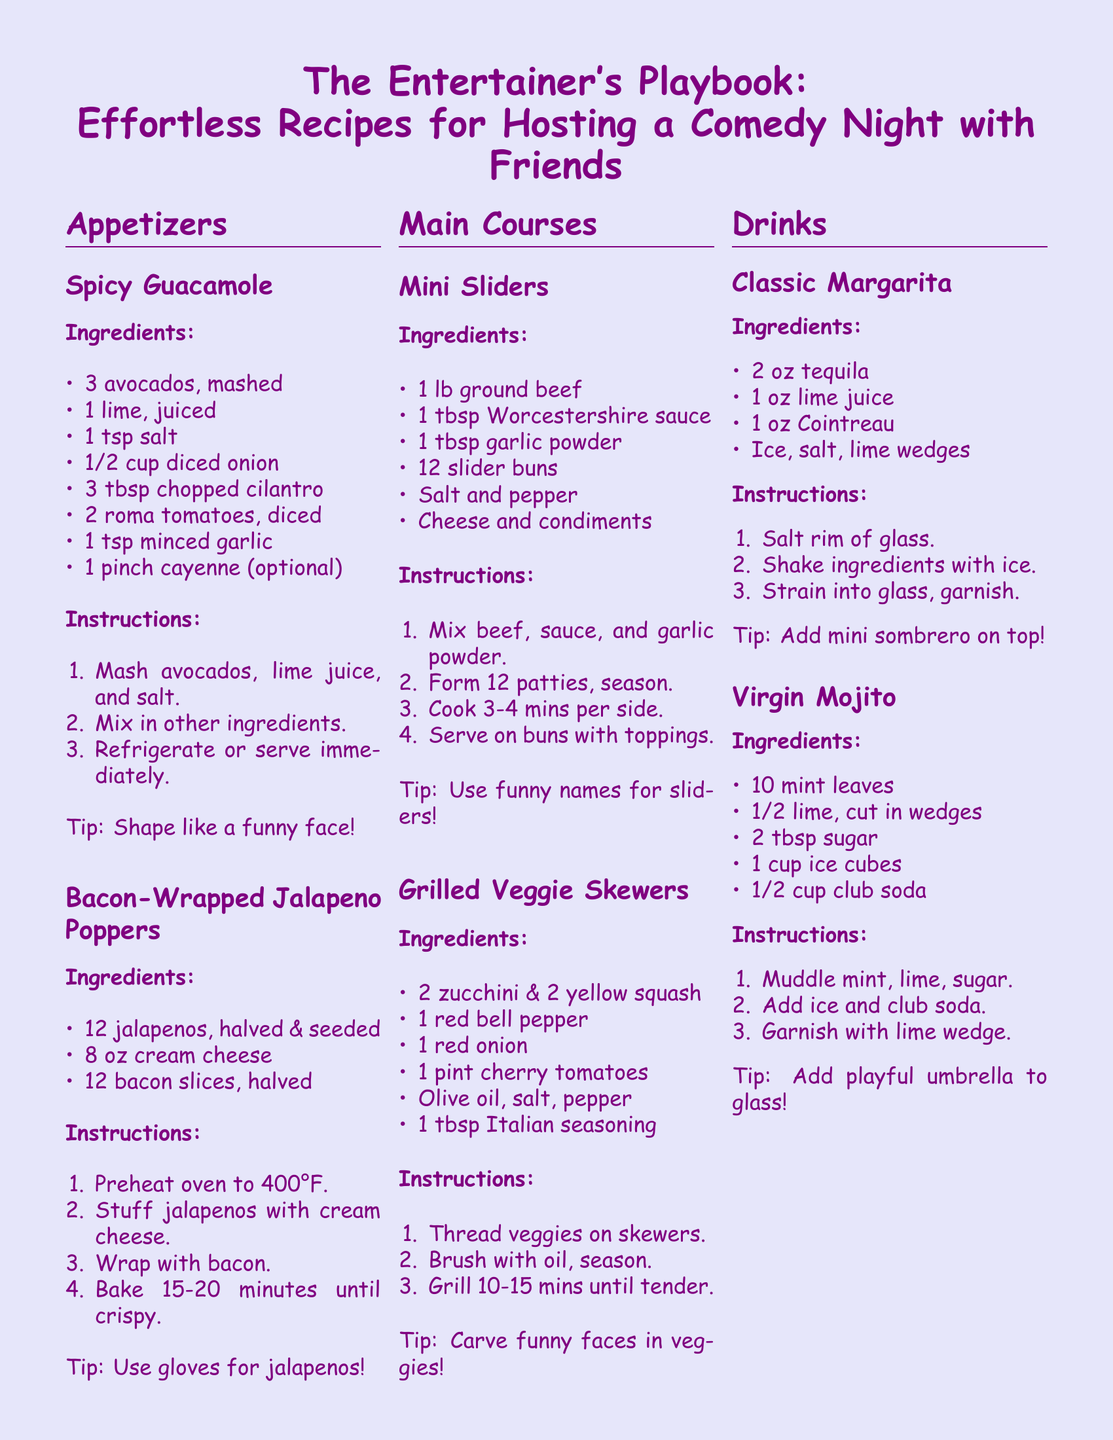What is the primary theme of the document? The document is focused on providing recipes and tips for hosting a comedy night with friends.
Answer: Hosting a comedy night How many ingredients are listed for the Spicy Guacamole? The ingredients for Spicy Guacamole include a total of 8 items.
Answer: 8 What dish has a tip about using gloves? The tip about using gloves refers to the preparation of Bacon-Wrapped Jalapeno Poppers.
Answer: Bacon-Wrapped Jalapeno Poppers What is the oven temperature for baking the bacon-wrapped jalapeno poppers? The recipe specifies that the oven should be preheated to 400°F for this dish.
Answer: 400°F What type of drink is suggested as a non-alcoholic option? The Virgin Mojito is presented as a non-alcoholic drink choice.
Answer: Virgin Mojito What playful accessory is suggested for the Classic Margarita? The document suggests adding a mini sombrero as a playful accessory for this drink.
Answer: Mini sombrero 